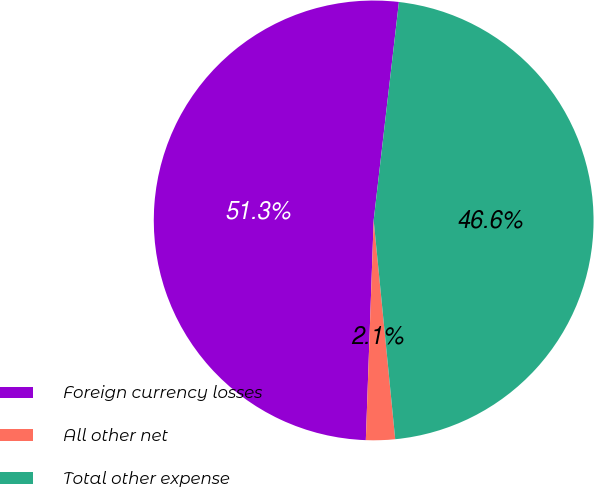Convert chart. <chart><loc_0><loc_0><loc_500><loc_500><pie_chart><fcel>Foreign currency losses<fcel>All other net<fcel>Total other expense<nl><fcel>51.26%<fcel>2.13%<fcel>46.6%<nl></chart> 